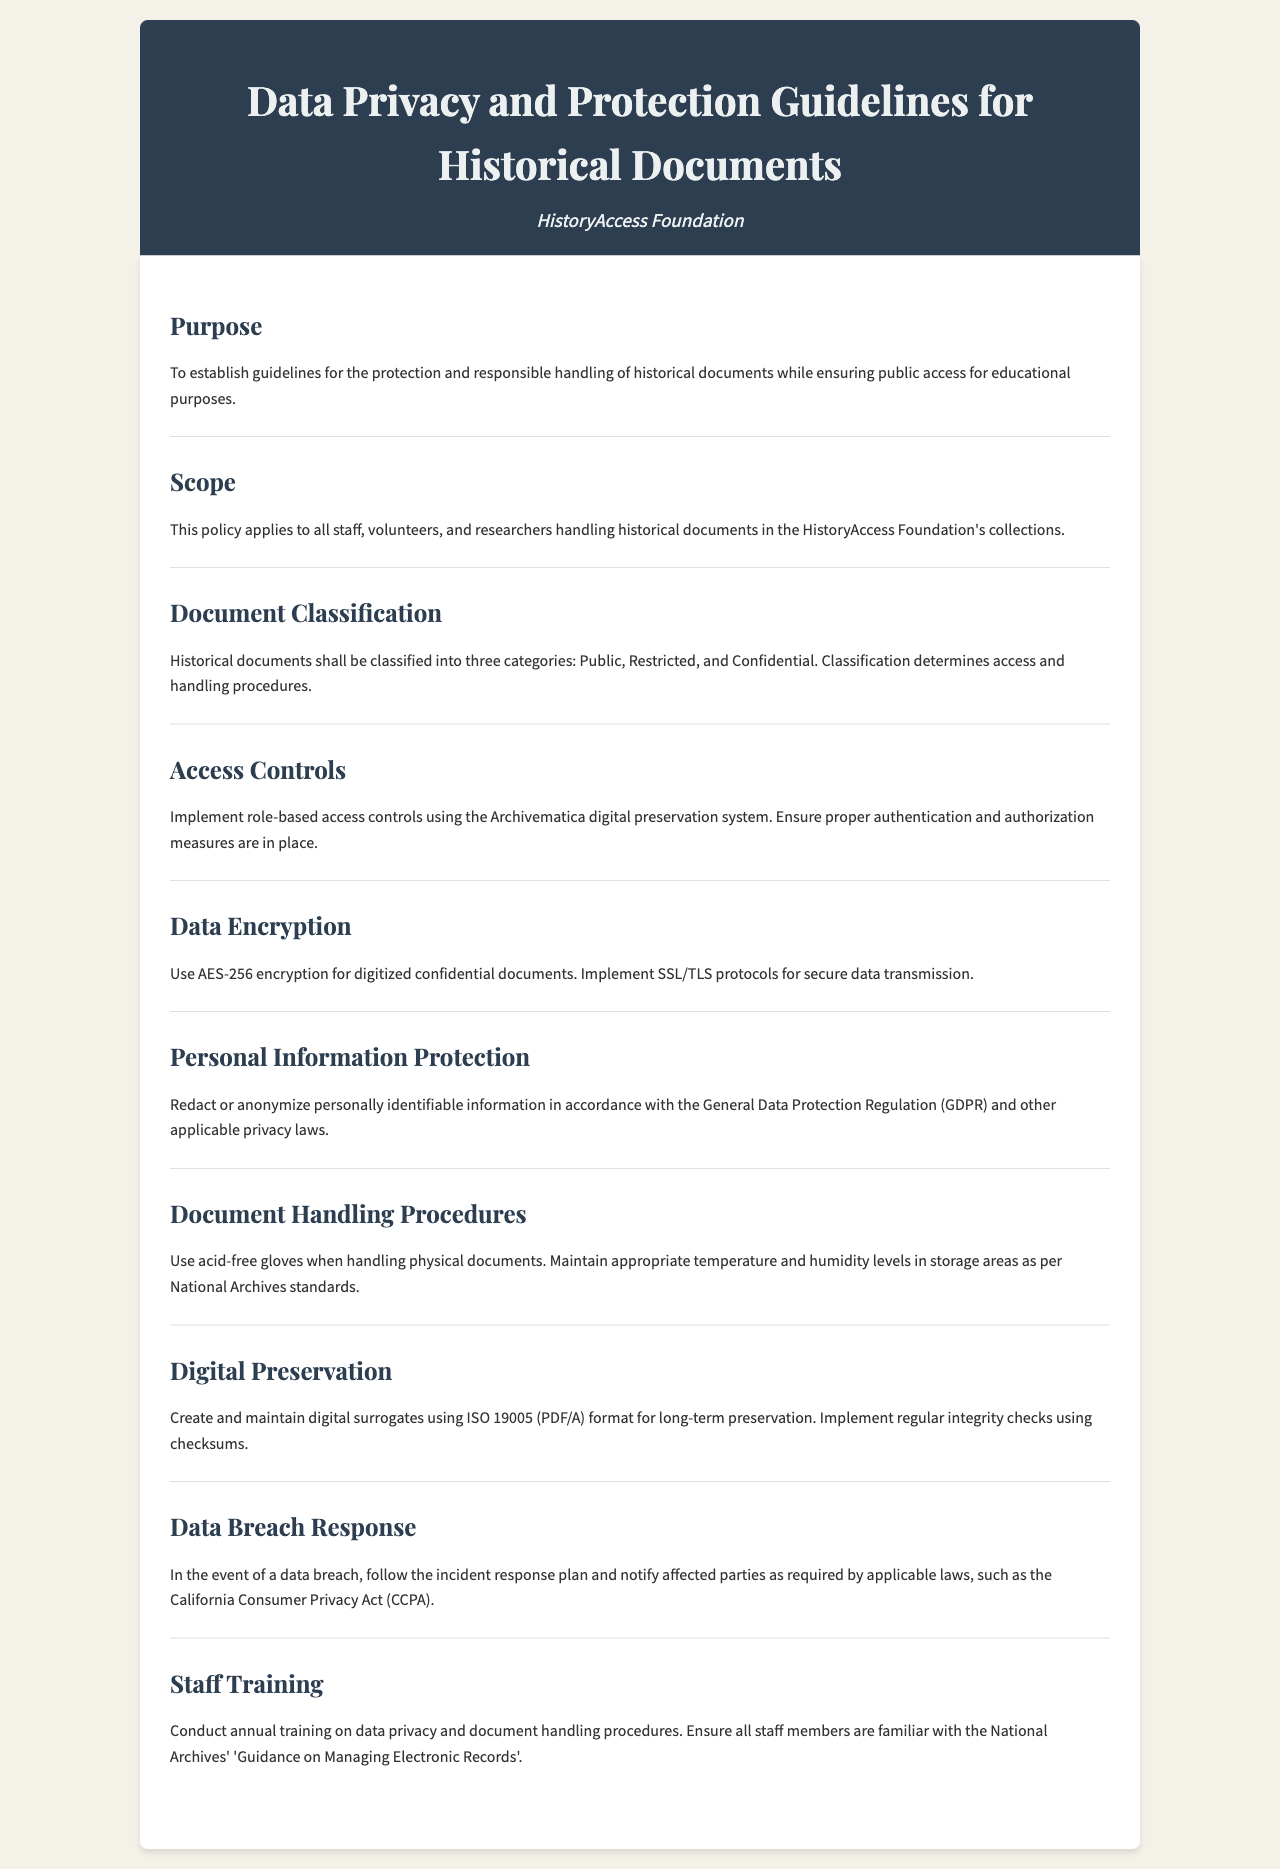What is the purpose of the guidelines? The purpose section of the document states that the guidelines are established for the protection and responsible handling of historical documents while ensuring public access for educational purposes.
Answer: Protection and responsible handling Who is the target audience of these guidelines? The scope section specifies that the guidelines apply to all staff, volunteers, and researchers handling historical documents in the HistoryAccess Foundation's collections.
Answer: Staff, volunteers, and researchers What are the three categories of document classification? The document classification section outlines that historical documents shall be classified into three categories: Public, Restricted, and Confidential.
Answer: Public, Restricted, Confidential What encryption standard is recommended for confidential documents? The data encryption section indicates that AES-256 encryption should be used for digitized confidential documents.
Answer: AES-256 What should be done in the event of a data breach? The data breach response section states that the incident response plan should be followed and affected parties must be notified as required by applicable laws.
Answer: Follow the incident response plan What kind of gloves should be used when handling documents? The document handling procedures section specifies the use of acid-free gloves when handling physical documents.
Answer: Acid-free gloves How often should staff training occur? The staff training section mentions that annual training on data privacy and document handling procedures should be conducted.
Answer: Annual What is the recommended format for digital surrogates? The digital preservation section states that digital surrogates should be created and maintained using ISO 19005 (PDF/A) format for long-term preservation.
Answer: ISO 19005 (PDF/A) What law requires notification of affected parties in case of a data breach? The data breach response section references the California Consumer Privacy Act (CCPA) as a law that requires notification of affected parties.
Answer: California Consumer Privacy Act (CCPA) 